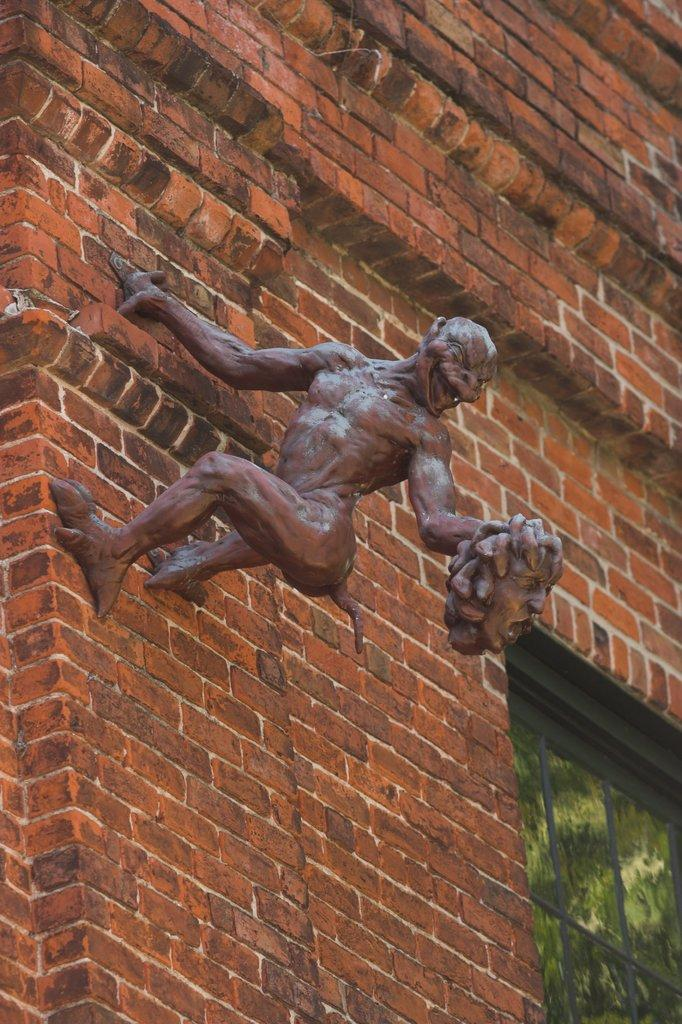What is the main subject in the middle of the image? There is a statue in the middle of the image. What can be seen on the right side of the image? There is a window on the right side of the image. What type of wall is visible in the background of the image? There is a brick wall in the background of the image. What type of zipper can be seen on the statue in the image? There is no zipper present on the statue in the image. Is there a maid visible in the image? There is no maid present in the image. 